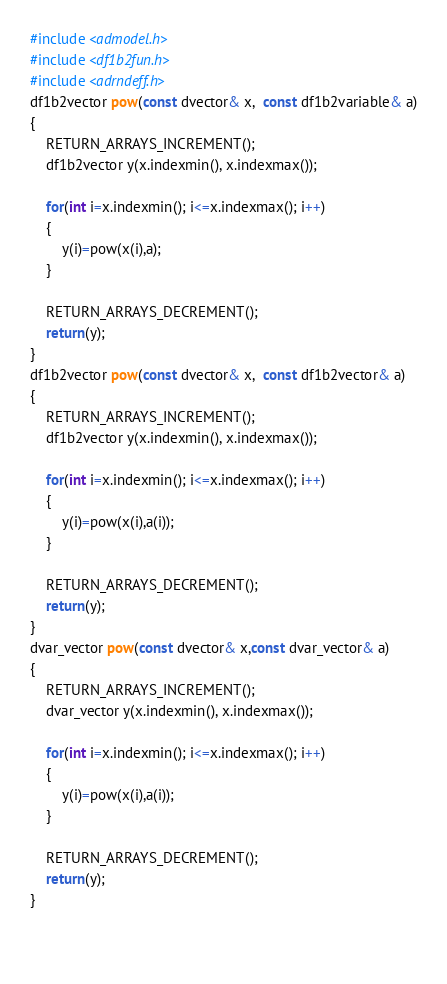Convert code to text. <code><loc_0><loc_0><loc_500><loc_500><_C++_>#include <admodel.h>
#include <df1b2fun.h>
#include <adrndeff.h> 
df1b2vector pow(const dvector& x,  const df1b2variable& a)
{
    RETURN_ARRAYS_INCREMENT();	
	df1b2vector y(x.indexmin(), x.indexmax());
	
	for(int i=x.indexmin(); i<=x.indexmax(); i++)
	{
		y(i)=pow(x(i),a);
	}	

	RETURN_ARRAYS_DECREMENT();	
    return(y);
}
df1b2vector pow(const dvector& x,  const df1b2vector& a)
{
    RETURN_ARRAYS_INCREMENT();	
	df1b2vector y(x.indexmin(), x.indexmax());
	
	for(int i=x.indexmin(); i<=x.indexmax(); i++)
	{
		y(i)=pow(x(i),a(i));
	}	

	RETURN_ARRAYS_DECREMENT();	
    return(y);
}
dvar_vector pow(const dvector& x,const dvar_vector& a)
{
    RETURN_ARRAYS_INCREMENT();	
	dvar_vector y(x.indexmin(), x.indexmax());

	for(int i=x.indexmin(); i<=x.indexmax(); i++)
	{
		y(i)=pow(x(i),a(i));
	}	

	RETURN_ARRAYS_DECREMENT();	
    return(y);
}
	
	
</code> 